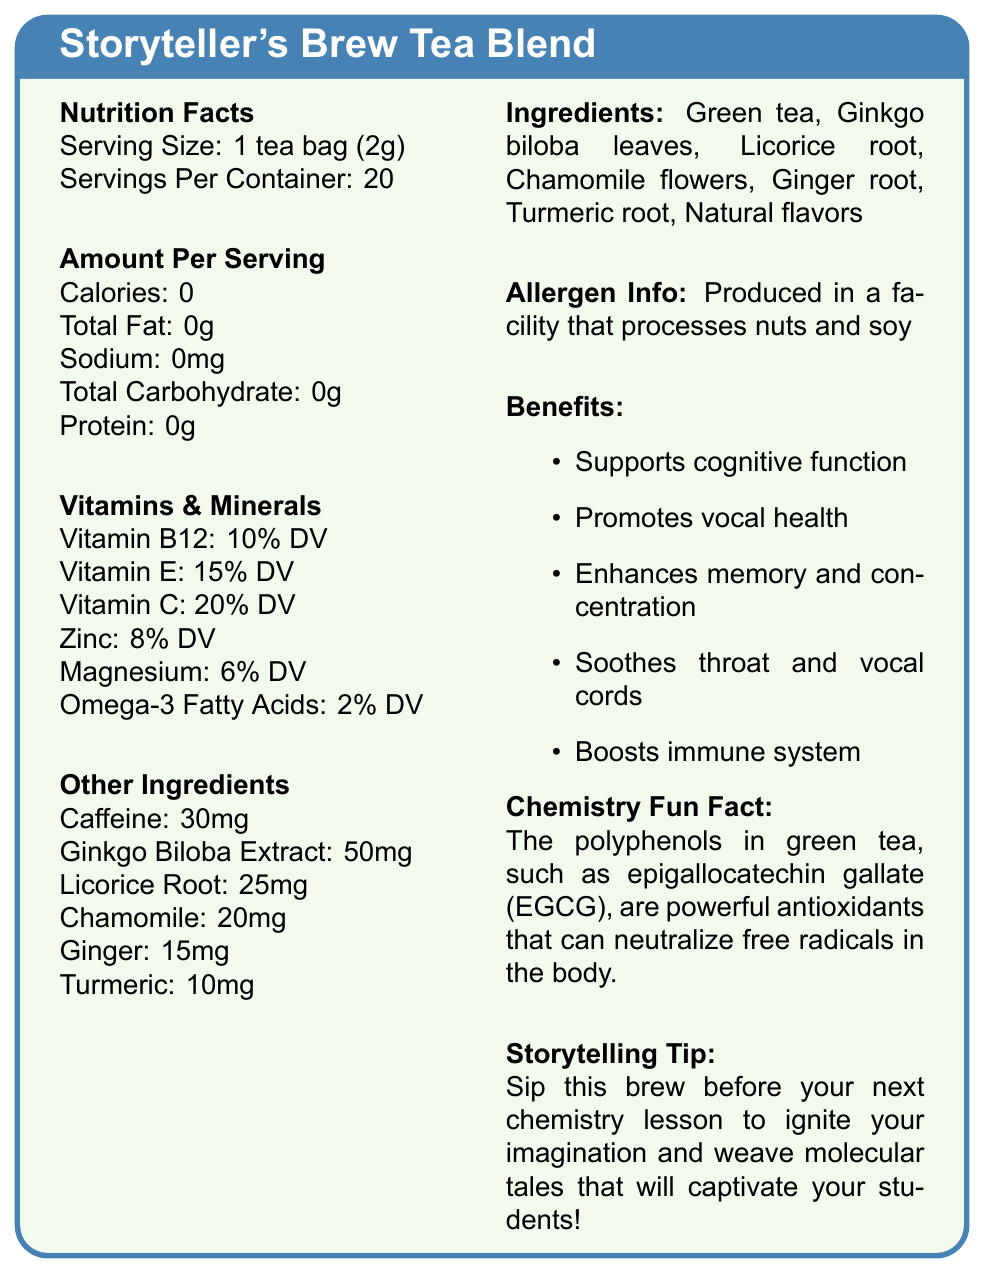what is the serving size of the Storyteller's Brew Tea Blend? The document lists the serving size as "1 tea bag (2g)".
Answer: 1 tea bag (2g) how many servings are there per container? The document states that there are 20 servings per container.
Answer: 20 how much caffeine is in each serving? The caffeine content per serving is listed as 30mg.
Answer: 30mg what vitamins are present in the tea blend? The document lists Vitamin B12, Vitamin E, and Vitamin C under the Vitamins & Minerals section.
Answer: Vitamin B12, Vitamin E, Vitamin C does the tea blend support cognitive function? Under the Benefits section, one of the listed benefits is that the tea blend supports cognitive function.
Answer: Yes what is the percentage daily value of Vitamin B12? A. 5% B. 10% C. 20% D. 15% The percentage daily value of Vitamin B12 is listed as 10%.
Answer: B. 10% which ingredient is present in the lowest amount? A. Chamomile B. Ginger C. Turmeric D. Licorice Root Turmeric is listed with 10mg, which is the lowest amount compared to other ingredients.
Answer: C. Turmeric is the tea blend produced in a facility that processes nuts and soy? The allergen information states that it is produced in a facility that processes nuts and soy.
Answer: Yes does the tea blend enhance memory? Enhancing memory and concentration is one of the benefits listed in the document.
Answer: Yes what is the main idea of the Storyteller's Brew Tea Blend document? The document offers insights into the nutritional values, ingredients, and benefits of the tea blend, specifically focusing on promoting cognitive function, vocal health, and other health benefits. Additionally, it includes a chemistry fun fact and a storytelling tip.
Answer: The document provides detailed nutritional information, ingredient list, benefits, and usage tips for the Storyteller's Brew Tea Blend, highlighting its support for cognitive function and vocal health. when was the Storyteller's Brew Tea Blend first introduced? The document does not provide any information about the introduction date of the tea blend.
Answer: Not enough information 